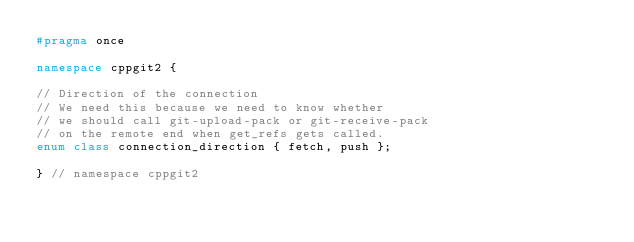<code> <loc_0><loc_0><loc_500><loc_500><_C++_>#pragma once

namespace cppgit2 {

// Direction of the connection
// We need this because we need to know whether
// we should call git-upload-pack or git-receive-pack
// on the remote end when get_refs gets called.
enum class connection_direction { fetch, push };

} // namespace cppgit2</code> 